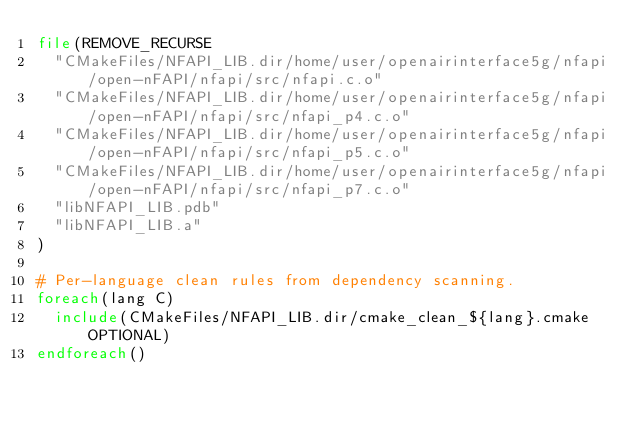Convert code to text. <code><loc_0><loc_0><loc_500><loc_500><_CMake_>file(REMOVE_RECURSE
  "CMakeFiles/NFAPI_LIB.dir/home/user/openairinterface5g/nfapi/open-nFAPI/nfapi/src/nfapi.c.o"
  "CMakeFiles/NFAPI_LIB.dir/home/user/openairinterface5g/nfapi/open-nFAPI/nfapi/src/nfapi_p4.c.o"
  "CMakeFiles/NFAPI_LIB.dir/home/user/openairinterface5g/nfapi/open-nFAPI/nfapi/src/nfapi_p5.c.o"
  "CMakeFiles/NFAPI_LIB.dir/home/user/openairinterface5g/nfapi/open-nFAPI/nfapi/src/nfapi_p7.c.o"
  "libNFAPI_LIB.pdb"
  "libNFAPI_LIB.a"
)

# Per-language clean rules from dependency scanning.
foreach(lang C)
  include(CMakeFiles/NFAPI_LIB.dir/cmake_clean_${lang}.cmake OPTIONAL)
endforeach()
</code> 